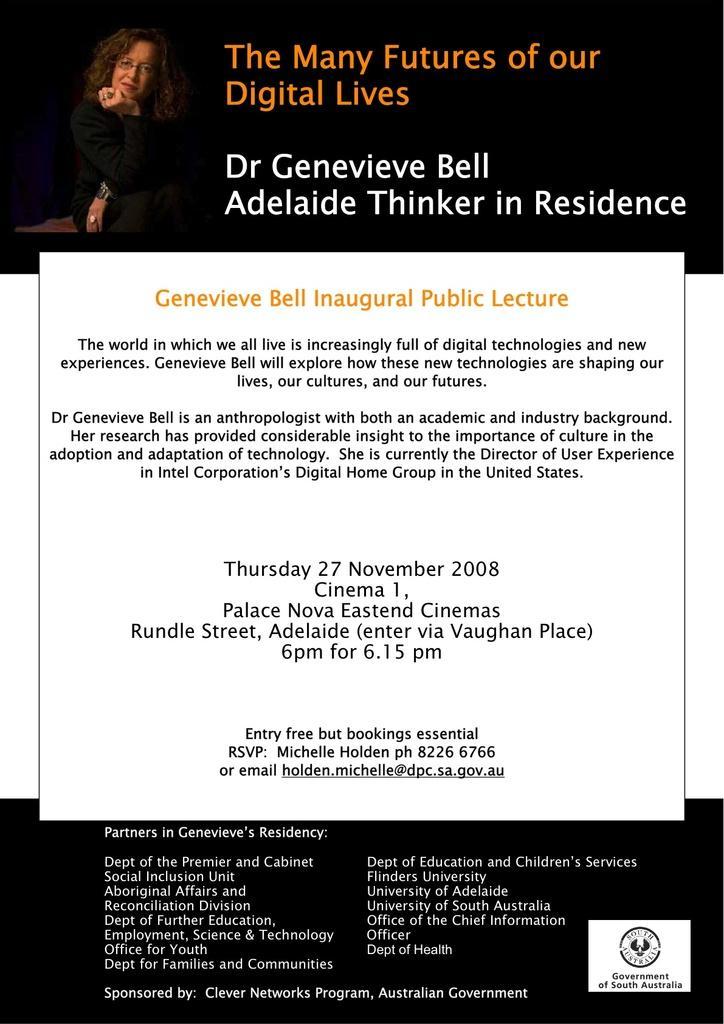In one or two sentences, can you explain what this image depicts? In this image there is an advertisement with a picture of a woman and some text written on it. 